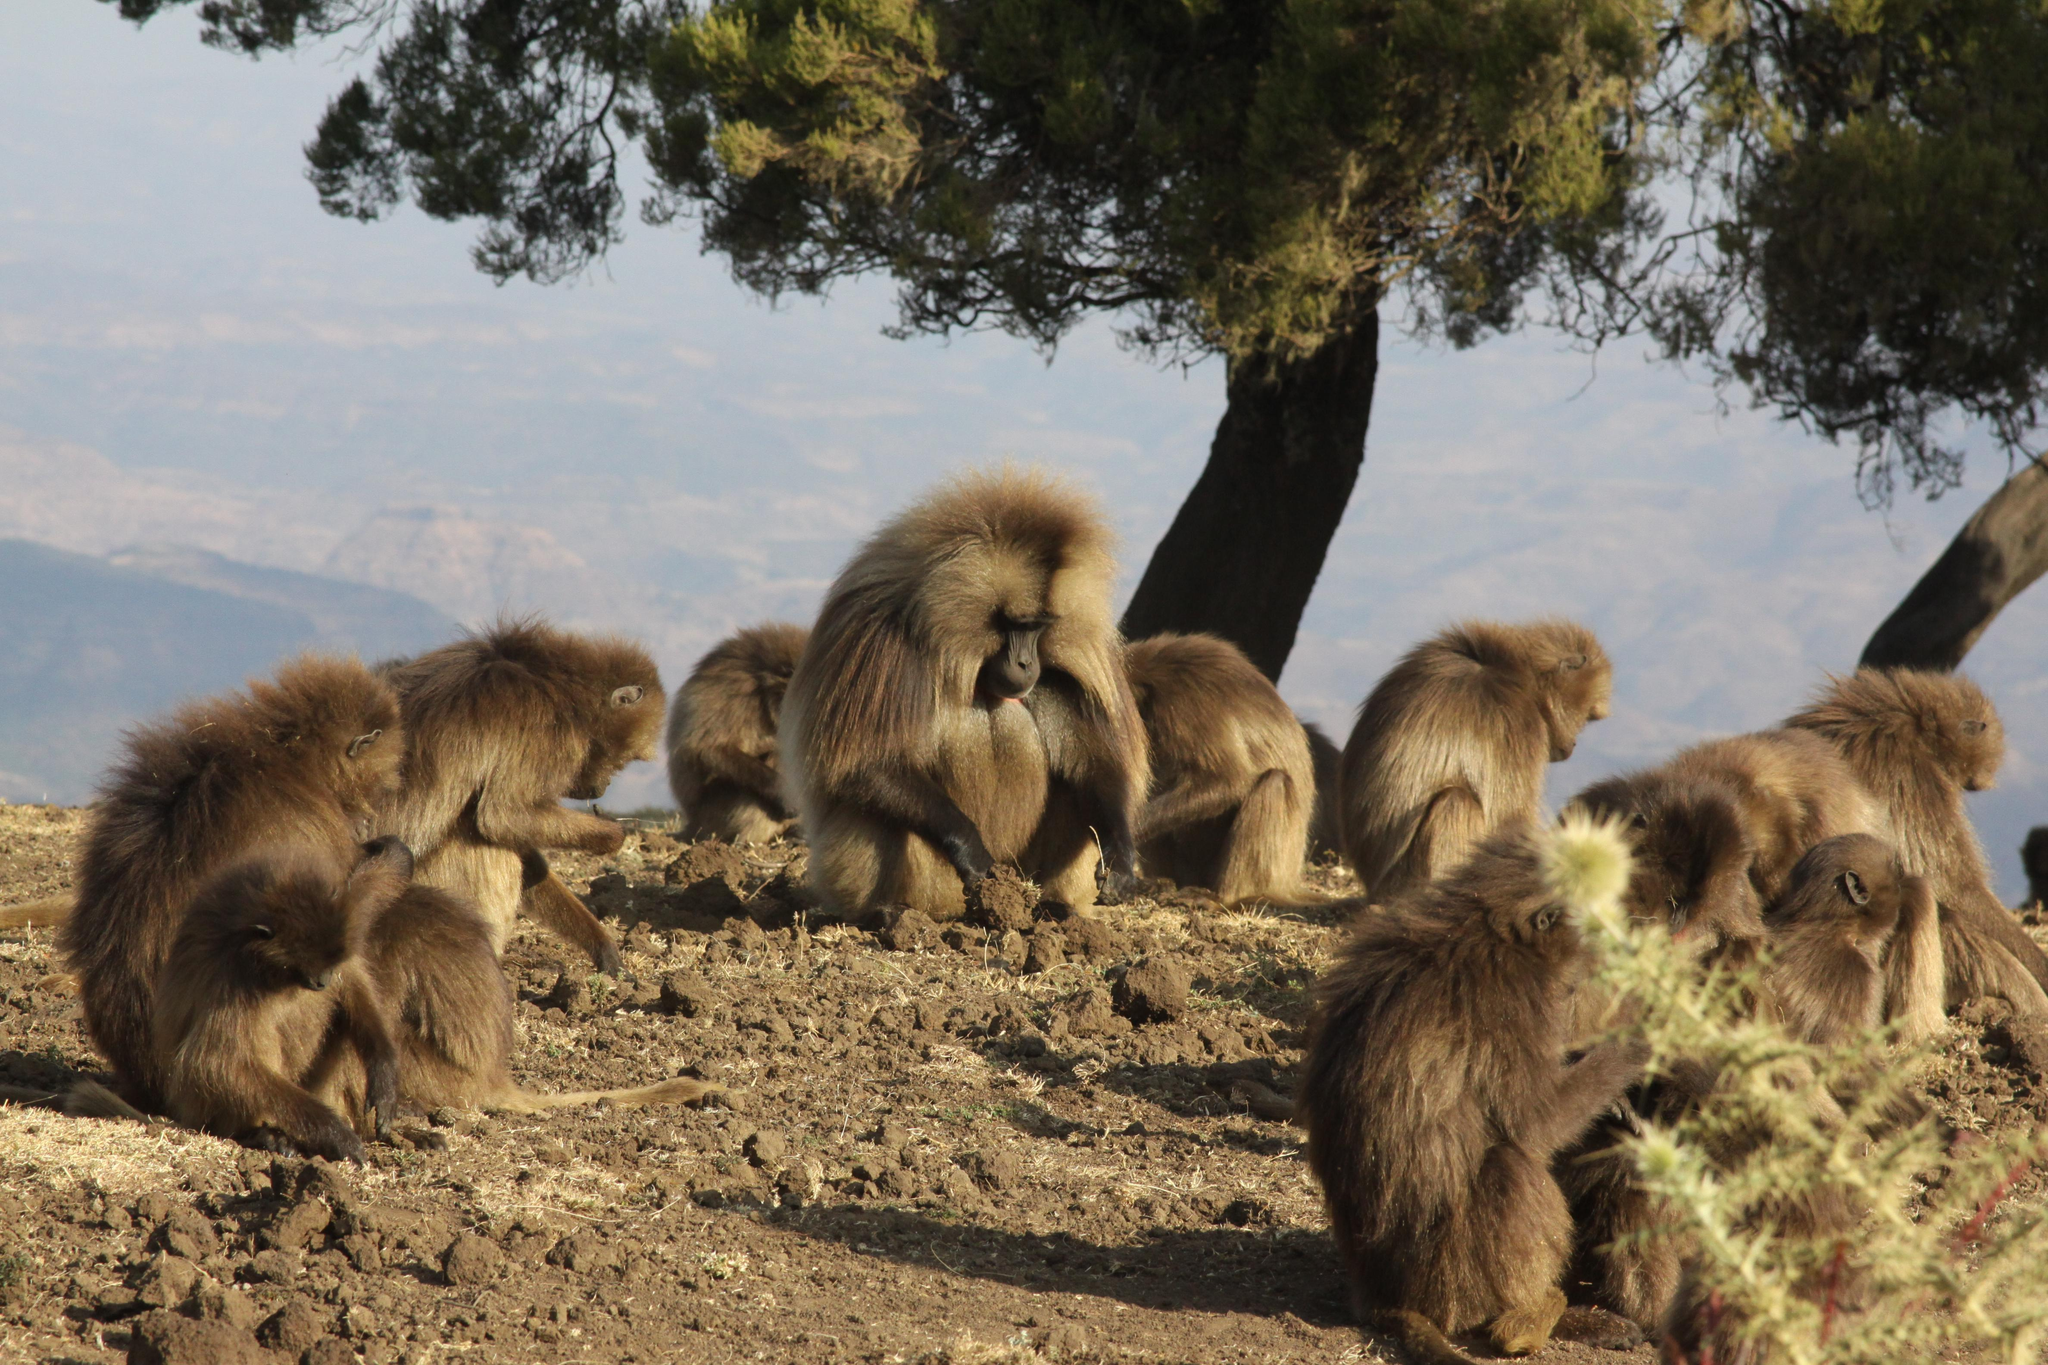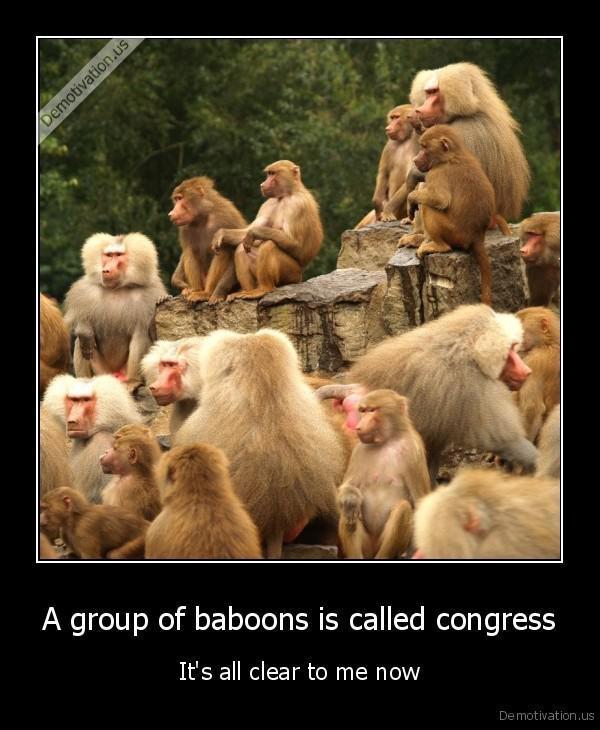The first image is the image on the left, the second image is the image on the right. For the images displayed, is the sentence "there are no more than four animals in the iage on the left" factually correct? Answer yes or no. No. 